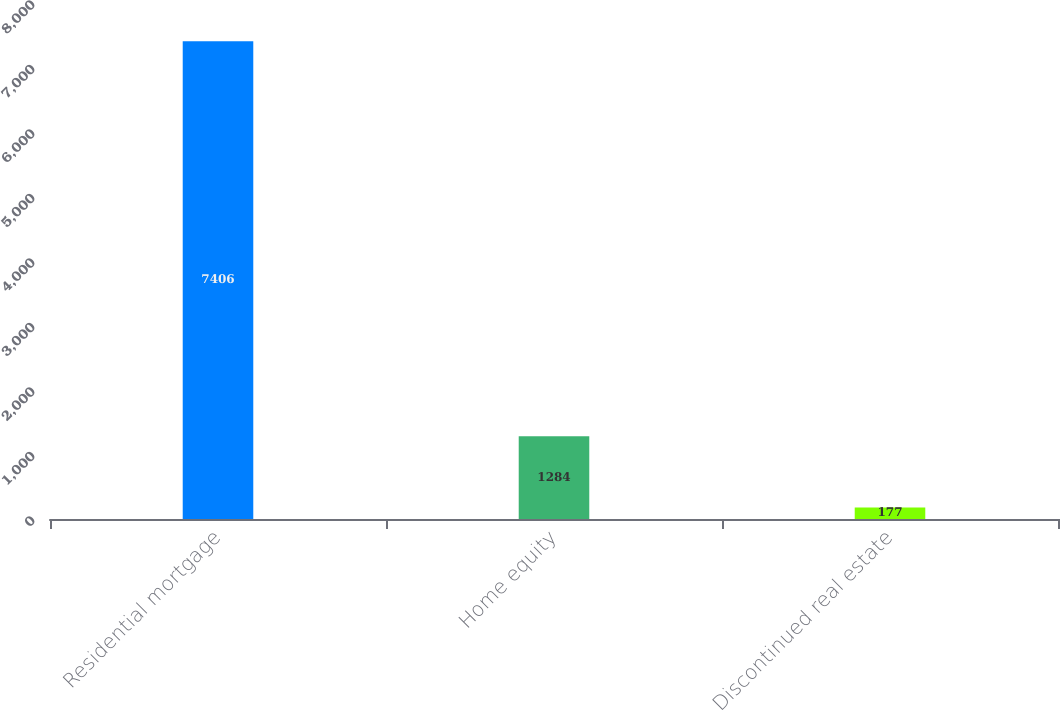Convert chart to OTSL. <chart><loc_0><loc_0><loc_500><loc_500><bar_chart><fcel>Residential mortgage<fcel>Home equity<fcel>Discontinued real estate<nl><fcel>7406<fcel>1284<fcel>177<nl></chart> 